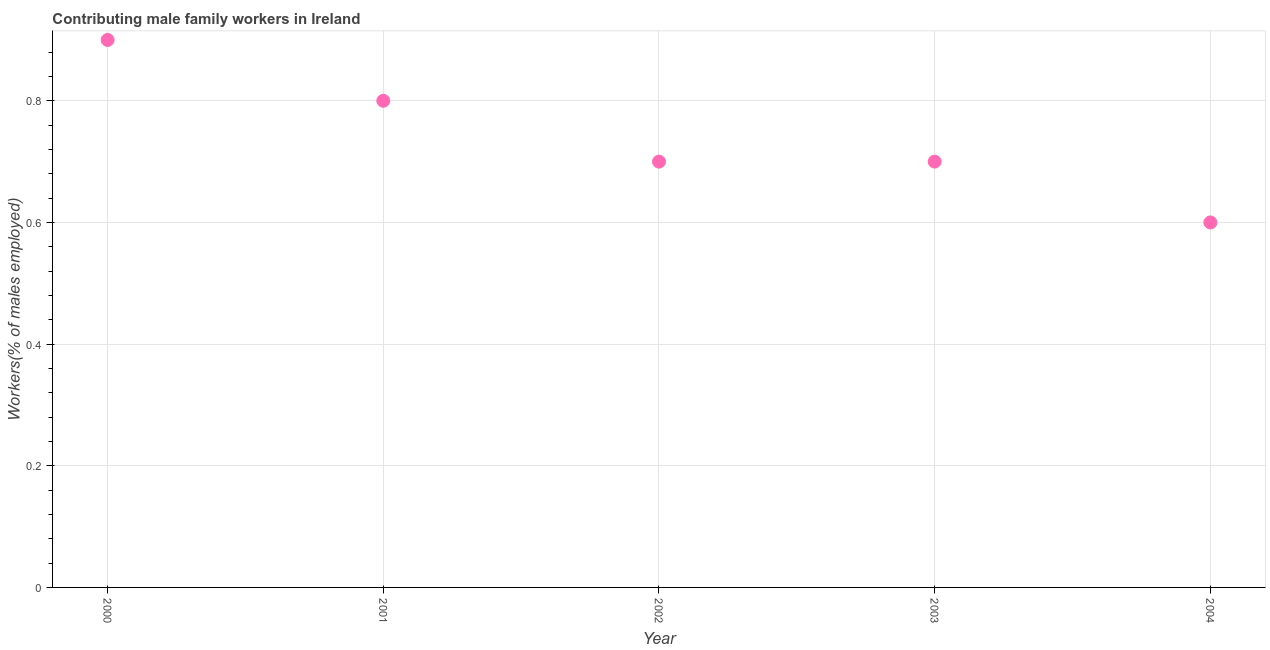What is the contributing male family workers in 2000?
Keep it short and to the point. 0.9. Across all years, what is the maximum contributing male family workers?
Ensure brevity in your answer.  0.9. Across all years, what is the minimum contributing male family workers?
Your response must be concise. 0.6. What is the sum of the contributing male family workers?
Provide a succinct answer. 3.7. What is the difference between the contributing male family workers in 2001 and 2004?
Provide a short and direct response. 0.2. What is the average contributing male family workers per year?
Offer a terse response. 0.74. What is the median contributing male family workers?
Make the answer very short. 0.7. In how many years, is the contributing male family workers greater than 0.4 %?
Your answer should be very brief. 5. Do a majority of the years between 2001 and 2003 (inclusive) have contributing male family workers greater than 0.6000000000000001 %?
Your answer should be very brief. Yes. What is the ratio of the contributing male family workers in 2003 to that in 2004?
Give a very brief answer. 1.17. Is the difference between the contributing male family workers in 2003 and 2004 greater than the difference between any two years?
Make the answer very short. No. What is the difference between the highest and the second highest contributing male family workers?
Offer a very short reply. 0.1. What is the difference between the highest and the lowest contributing male family workers?
Provide a short and direct response. 0.3. In how many years, is the contributing male family workers greater than the average contributing male family workers taken over all years?
Your answer should be very brief. 2. How many dotlines are there?
Make the answer very short. 1. What is the title of the graph?
Make the answer very short. Contributing male family workers in Ireland. What is the label or title of the X-axis?
Your response must be concise. Year. What is the label or title of the Y-axis?
Your response must be concise. Workers(% of males employed). What is the Workers(% of males employed) in 2000?
Provide a succinct answer. 0.9. What is the Workers(% of males employed) in 2001?
Your answer should be compact. 0.8. What is the Workers(% of males employed) in 2002?
Make the answer very short. 0.7. What is the Workers(% of males employed) in 2003?
Make the answer very short. 0.7. What is the Workers(% of males employed) in 2004?
Your answer should be compact. 0.6. What is the difference between the Workers(% of males employed) in 2000 and 2002?
Offer a very short reply. 0.2. What is the difference between the Workers(% of males employed) in 2000 and 2004?
Provide a short and direct response. 0.3. What is the difference between the Workers(% of males employed) in 2001 and 2003?
Ensure brevity in your answer.  0.1. What is the difference between the Workers(% of males employed) in 2003 and 2004?
Your answer should be compact. 0.1. What is the ratio of the Workers(% of males employed) in 2000 to that in 2001?
Offer a very short reply. 1.12. What is the ratio of the Workers(% of males employed) in 2000 to that in 2002?
Your answer should be compact. 1.29. What is the ratio of the Workers(% of males employed) in 2000 to that in 2003?
Offer a very short reply. 1.29. What is the ratio of the Workers(% of males employed) in 2000 to that in 2004?
Offer a very short reply. 1.5. What is the ratio of the Workers(% of males employed) in 2001 to that in 2002?
Give a very brief answer. 1.14. What is the ratio of the Workers(% of males employed) in 2001 to that in 2003?
Offer a very short reply. 1.14. What is the ratio of the Workers(% of males employed) in 2001 to that in 2004?
Your response must be concise. 1.33. What is the ratio of the Workers(% of males employed) in 2002 to that in 2004?
Provide a succinct answer. 1.17. What is the ratio of the Workers(% of males employed) in 2003 to that in 2004?
Your response must be concise. 1.17. 